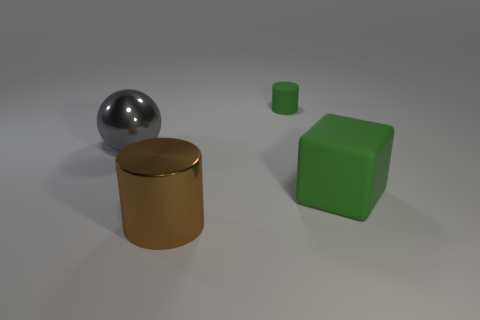What number of green matte cubes have the same size as the shiny sphere?
Offer a terse response. 1. The sphere is what color?
Provide a succinct answer. Gray. There is a sphere; is its color the same as the cylinder that is in front of the gray shiny thing?
Your response must be concise. No. There is a object that is the same material as the block; what size is it?
Your answer should be very brief. Small. Is there a metal thing of the same color as the big metal cylinder?
Your answer should be very brief. No. How many things are objects on the right side of the small green thing or small purple matte spheres?
Provide a short and direct response. 1. Does the big green cube have the same material as the cylinder in front of the green rubber cylinder?
Make the answer very short. No. There is a matte cylinder that is the same color as the matte block; what is its size?
Make the answer very short. Small. Is there a small purple ball made of the same material as the large cylinder?
Offer a very short reply. No. How many things are green rubber objects in front of the gray metallic thing or things to the right of the metallic ball?
Offer a very short reply. 3. 